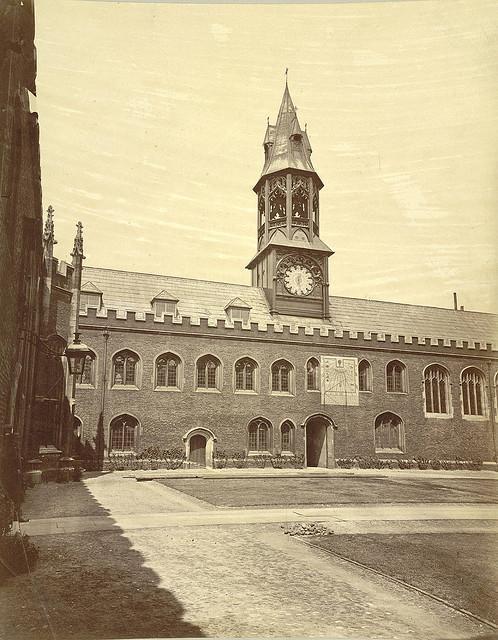How many doors are there?
Give a very brief answer. 2. How many windows are on the building?
Give a very brief answer. 15. 